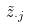<formula> <loc_0><loc_0><loc_500><loc_500>\tilde { z } _ { \cdot j }</formula> 